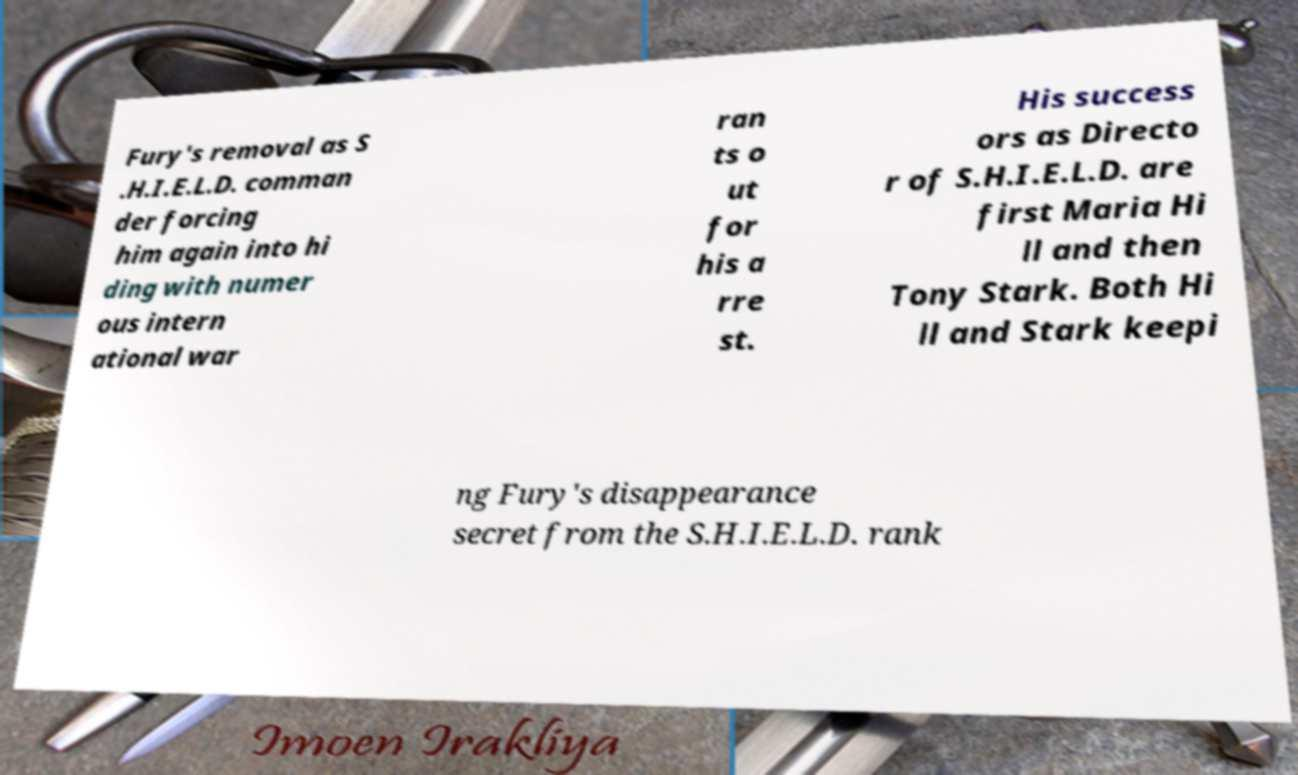Could you extract and type out the text from this image? Fury's removal as S .H.I.E.L.D. comman der forcing him again into hi ding with numer ous intern ational war ran ts o ut for his a rre st. His success ors as Directo r of S.H.I.E.L.D. are first Maria Hi ll and then Tony Stark. Both Hi ll and Stark keepi ng Fury's disappearance secret from the S.H.I.E.L.D. rank 